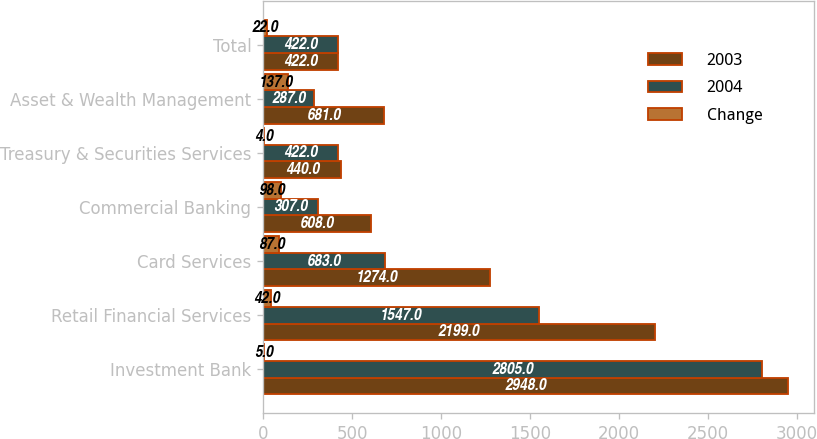Convert chart. <chart><loc_0><loc_0><loc_500><loc_500><stacked_bar_chart><ecel><fcel>Investment Bank<fcel>Retail Financial Services<fcel>Card Services<fcel>Commercial Banking<fcel>Treasury & Securities Services<fcel>Asset & Wealth Management<fcel>Total<nl><fcel>2003<fcel>2948<fcel>2199<fcel>1274<fcel>608<fcel>440<fcel>681<fcel>422<nl><fcel>2004<fcel>2805<fcel>1547<fcel>683<fcel>307<fcel>422<fcel>287<fcel>422<nl><fcel>Change<fcel>5<fcel>42<fcel>87<fcel>98<fcel>4<fcel>137<fcel>22<nl></chart> 